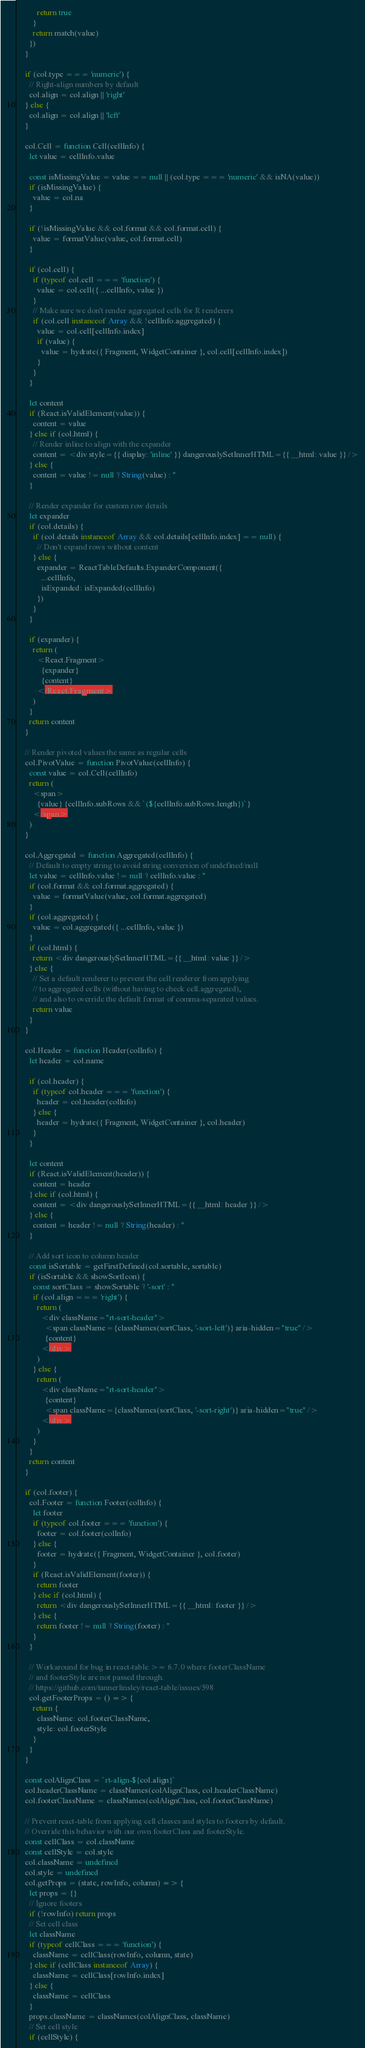Convert code to text. <code><loc_0><loc_0><loc_500><loc_500><_JavaScript_>          return true
        }
        return match(value)
      })
    }

    if (col.type === 'numeric') {
      // Right-align numbers by default
      col.align = col.align || 'right'
    } else {
      col.align = col.align || 'left'
    }

    col.Cell = function Cell(cellInfo) {
      let value = cellInfo.value

      const isMissingValue = value == null || (col.type === 'numeric' && isNA(value))
      if (isMissingValue) {
        value = col.na
      }

      if (!isMissingValue && col.format && col.format.cell) {
        value = formatValue(value, col.format.cell)
      }

      if (col.cell) {
        if (typeof col.cell === 'function') {
          value = col.cell({ ...cellInfo, value })
        }
        // Make sure we don't render aggregated cells for R renderers
        if (col.cell instanceof Array && !cellInfo.aggregated) {
          value = col.cell[cellInfo.index]
          if (value) {
            value = hydrate({ Fragment, WidgetContainer }, col.cell[cellInfo.index])
          }
        }
      }

      let content
      if (React.isValidElement(value)) {
        content = value
      } else if (col.html) {
        // Render inline to align with the expander
        content = <div style={{ display: 'inline' }} dangerouslySetInnerHTML={{ __html: value }} />
      } else {
        content = value != null ? String(value) : ''
      }

      // Render expander for custom row details
      let expander
      if (col.details) {
        if (col.details instanceof Array && col.details[cellInfo.index] == null) {
          // Don't expand rows without content
        } else {
          expander = ReactTableDefaults.ExpanderComponent({
            ...cellInfo,
            isExpanded: isExpanded(cellInfo)
          })
        }
      }

      if (expander) {
        return (
          <React.Fragment>
            {expander}
            {content}
          </React.Fragment>
        )
      }
      return content
    }

    // Render pivoted values the same as regular cells
    col.PivotValue = function PivotValue(cellInfo) {
      const value = col.Cell(cellInfo)
      return (
        <span>
          {value} {cellInfo.subRows && `(${cellInfo.subRows.length})`}
        </span>
      )
    }

    col.Aggregated = function Aggregated(cellInfo) {
      // Default to empty string to avoid string conversion of undefined/null
      let value = cellInfo.value != null ? cellInfo.value : ''
      if (col.format && col.format.aggregated) {
        value = formatValue(value, col.format.aggregated)
      }
      if (col.aggregated) {
        value = col.aggregated({ ...cellInfo, value })
      }
      if (col.html) {
        return <div dangerouslySetInnerHTML={{ __html: value }} />
      } else {
        // Set a default renderer to prevent the cell renderer from applying
        // to aggregated cells (without having to check cell.aggregated),
        // and also to override the default format of comma-separated values.
        return value
      }
    }

    col.Header = function Header(colInfo) {
      let header = col.name

      if (col.header) {
        if (typeof col.header === 'function') {
          header = col.header(colInfo)
        } else {
          header = hydrate({ Fragment, WidgetContainer }, col.header)
        }
      }

      let content
      if (React.isValidElement(header)) {
        content = header
      } else if (col.html) {
        content = <div dangerouslySetInnerHTML={{ __html: header }} />
      } else {
        content = header != null ? String(header) : ''
      }

      // Add sort icon to column header
      const isSortable = getFirstDefined(col.sortable, sortable)
      if (isSortable && showSortIcon) {
        const sortClass = showSortable ? '-sort' : ''
        if (col.align === 'right') {
          return (
            <div className="rt-sort-header">
              <span className={classNames(sortClass, '-sort-left')} aria-hidden="true" />
              {content}
            </div>
          )
        } else {
          return (
            <div className="rt-sort-header">
              {content}
              <span className={classNames(sortClass, '-sort-right')} aria-hidden="true" />
            </div>
          )
        }
      }
      return content
    }

    if (col.footer) {
      col.Footer = function Footer(colInfo) {
        let footer
        if (typeof col.footer === 'function') {
          footer = col.footer(colInfo)
        } else {
          footer = hydrate({ Fragment, WidgetContainer }, col.footer)
        }
        if (React.isValidElement(footer)) {
          return footer
        } else if (col.html) {
          return <div dangerouslySetInnerHTML={{ __html: footer }} />
        } else {
          return footer != null ? String(footer) : ''
        }
      }

      // Workaround for bug in react-table >= 6.7.0 where footerClassName
      // and footerStyle are not passed through.
      // https://github.com/tannerlinsley/react-table/issues/598
      col.getFooterProps = () => {
        return {
          className: col.footerClassName,
          style: col.footerStyle
        }
      }
    }

    const colAlignClass = `rt-align-${col.align}`
    col.headerClassName = classNames(colAlignClass, col.headerClassName)
    col.footerClassName = classNames(colAlignClass, col.footerClassName)

    // Prevent react-table from applying cell classes and styles to footers by default.
    // Override this behavior with our own footerClass and footerStyle.
    const cellClass = col.className
    const cellStyle = col.style
    col.className = undefined
    col.style = undefined
    col.getProps = (state, rowInfo, column) => {
      let props = {}
      // Ignore footers
      if (!rowInfo) return props
      // Set cell class
      let className
      if (typeof cellClass === 'function') {
        className = cellClass(rowInfo, column, state)
      } else if (cellClass instanceof Array) {
        className = cellClass[rowInfo.index]
      } else {
        className = cellClass
      }
      props.className = classNames(colAlignClass, className)
      // Set cell style
      if (cellStyle) {</code> 